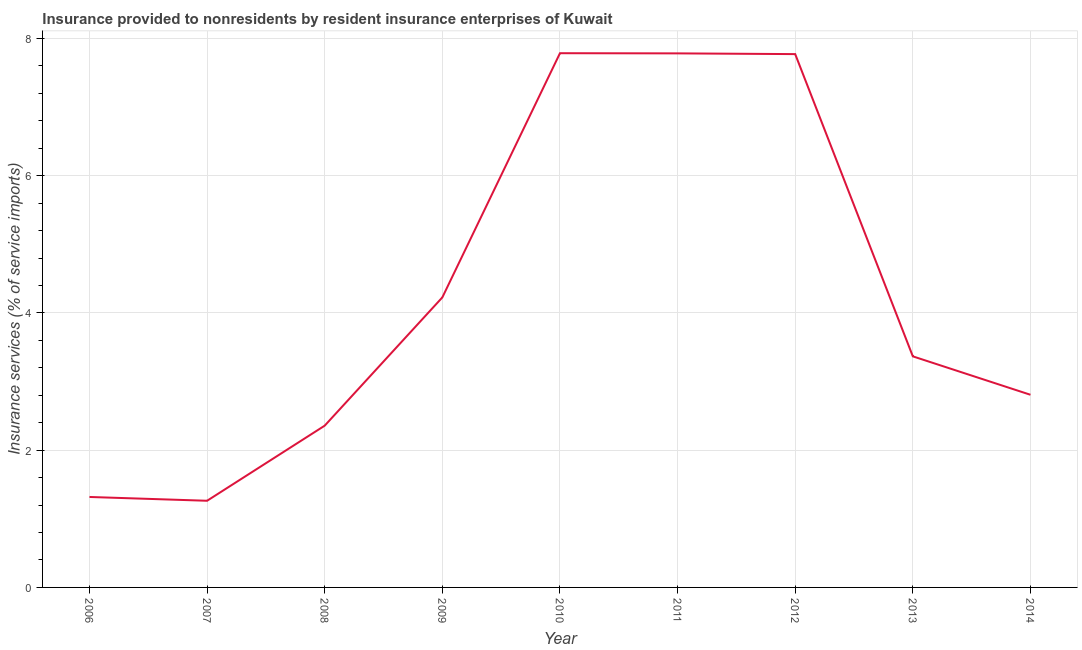What is the insurance and financial services in 2013?
Provide a succinct answer. 3.37. Across all years, what is the maximum insurance and financial services?
Ensure brevity in your answer.  7.79. Across all years, what is the minimum insurance and financial services?
Your answer should be very brief. 1.26. In which year was the insurance and financial services minimum?
Your response must be concise. 2007. What is the sum of the insurance and financial services?
Your response must be concise. 38.68. What is the difference between the insurance and financial services in 2009 and 2012?
Your answer should be compact. -3.55. What is the average insurance and financial services per year?
Offer a very short reply. 4.3. What is the median insurance and financial services?
Your response must be concise. 3.37. Do a majority of the years between 2009 and 2007 (inclusive) have insurance and financial services greater than 4 %?
Offer a very short reply. No. What is the ratio of the insurance and financial services in 2010 to that in 2012?
Your answer should be compact. 1. What is the difference between the highest and the second highest insurance and financial services?
Give a very brief answer. 0. Is the sum of the insurance and financial services in 2006 and 2012 greater than the maximum insurance and financial services across all years?
Provide a short and direct response. Yes. What is the difference between the highest and the lowest insurance and financial services?
Your answer should be compact. 6.52. Does the insurance and financial services monotonically increase over the years?
Provide a succinct answer. No. What is the difference between two consecutive major ticks on the Y-axis?
Keep it short and to the point. 2. Are the values on the major ticks of Y-axis written in scientific E-notation?
Ensure brevity in your answer.  No. Does the graph contain any zero values?
Your response must be concise. No. What is the title of the graph?
Provide a short and direct response. Insurance provided to nonresidents by resident insurance enterprises of Kuwait. What is the label or title of the X-axis?
Keep it short and to the point. Year. What is the label or title of the Y-axis?
Offer a terse response. Insurance services (% of service imports). What is the Insurance services (% of service imports) in 2006?
Your answer should be compact. 1.32. What is the Insurance services (% of service imports) in 2007?
Offer a terse response. 1.26. What is the Insurance services (% of service imports) of 2008?
Keep it short and to the point. 2.36. What is the Insurance services (% of service imports) of 2009?
Provide a short and direct response. 4.23. What is the Insurance services (% of service imports) of 2010?
Keep it short and to the point. 7.79. What is the Insurance services (% of service imports) in 2011?
Offer a very short reply. 7.78. What is the Insurance services (% of service imports) in 2012?
Keep it short and to the point. 7.77. What is the Insurance services (% of service imports) of 2013?
Ensure brevity in your answer.  3.37. What is the Insurance services (% of service imports) in 2014?
Your response must be concise. 2.81. What is the difference between the Insurance services (% of service imports) in 2006 and 2007?
Keep it short and to the point. 0.06. What is the difference between the Insurance services (% of service imports) in 2006 and 2008?
Ensure brevity in your answer.  -1.04. What is the difference between the Insurance services (% of service imports) in 2006 and 2009?
Give a very brief answer. -2.91. What is the difference between the Insurance services (% of service imports) in 2006 and 2010?
Make the answer very short. -6.47. What is the difference between the Insurance services (% of service imports) in 2006 and 2011?
Keep it short and to the point. -6.47. What is the difference between the Insurance services (% of service imports) in 2006 and 2012?
Provide a succinct answer. -6.45. What is the difference between the Insurance services (% of service imports) in 2006 and 2013?
Your answer should be very brief. -2.05. What is the difference between the Insurance services (% of service imports) in 2006 and 2014?
Your response must be concise. -1.49. What is the difference between the Insurance services (% of service imports) in 2007 and 2008?
Give a very brief answer. -1.09. What is the difference between the Insurance services (% of service imports) in 2007 and 2009?
Provide a short and direct response. -2.96. What is the difference between the Insurance services (% of service imports) in 2007 and 2010?
Provide a short and direct response. -6.52. What is the difference between the Insurance services (% of service imports) in 2007 and 2011?
Keep it short and to the point. -6.52. What is the difference between the Insurance services (% of service imports) in 2007 and 2012?
Ensure brevity in your answer.  -6.51. What is the difference between the Insurance services (% of service imports) in 2007 and 2013?
Make the answer very short. -2.1. What is the difference between the Insurance services (% of service imports) in 2007 and 2014?
Give a very brief answer. -1.54. What is the difference between the Insurance services (% of service imports) in 2008 and 2009?
Provide a succinct answer. -1.87. What is the difference between the Insurance services (% of service imports) in 2008 and 2010?
Provide a short and direct response. -5.43. What is the difference between the Insurance services (% of service imports) in 2008 and 2011?
Provide a short and direct response. -5.43. What is the difference between the Insurance services (% of service imports) in 2008 and 2012?
Your answer should be compact. -5.42. What is the difference between the Insurance services (% of service imports) in 2008 and 2013?
Your answer should be very brief. -1.01. What is the difference between the Insurance services (% of service imports) in 2008 and 2014?
Your answer should be compact. -0.45. What is the difference between the Insurance services (% of service imports) in 2009 and 2010?
Keep it short and to the point. -3.56. What is the difference between the Insurance services (% of service imports) in 2009 and 2011?
Keep it short and to the point. -3.56. What is the difference between the Insurance services (% of service imports) in 2009 and 2012?
Your answer should be very brief. -3.55. What is the difference between the Insurance services (% of service imports) in 2009 and 2013?
Ensure brevity in your answer.  0.86. What is the difference between the Insurance services (% of service imports) in 2009 and 2014?
Offer a very short reply. 1.42. What is the difference between the Insurance services (% of service imports) in 2010 and 2011?
Give a very brief answer. 0. What is the difference between the Insurance services (% of service imports) in 2010 and 2012?
Provide a short and direct response. 0.01. What is the difference between the Insurance services (% of service imports) in 2010 and 2013?
Offer a very short reply. 4.42. What is the difference between the Insurance services (% of service imports) in 2010 and 2014?
Give a very brief answer. 4.98. What is the difference between the Insurance services (% of service imports) in 2011 and 2012?
Offer a terse response. 0.01. What is the difference between the Insurance services (% of service imports) in 2011 and 2013?
Your answer should be compact. 4.42. What is the difference between the Insurance services (% of service imports) in 2011 and 2014?
Provide a succinct answer. 4.98. What is the difference between the Insurance services (% of service imports) in 2012 and 2013?
Keep it short and to the point. 4.4. What is the difference between the Insurance services (% of service imports) in 2012 and 2014?
Provide a short and direct response. 4.96. What is the difference between the Insurance services (% of service imports) in 2013 and 2014?
Offer a very short reply. 0.56. What is the ratio of the Insurance services (% of service imports) in 2006 to that in 2007?
Provide a succinct answer. 1.04. What is the ratio of the Insurance services (% of service imports) in 2006 to that in 2008?
Your response must be concise. 0.56. What is the ratio of the Insurance services (% of service imports) in 2006 to that in 2009?
Provide a succinct answer. 0.31. What is the ratio of the Insurance services (% of service imports) in 2006 to that in 2010?
Provide a short and direct response. 0.17. What is the ratio of the Insurance services (% of service imports) in 2006 to that in 2011?
Your response must be concise. 0.17. What is the ratio of the Insurance services (% of service imports) in 2006 to that in 2012?
Your answer should be very brief. 0.17. What is the ratio of the Insurance services (% of service imports) in 2006 to that in 2013?
Keep it short and to the point. 0.39. What is the ratio of the Insurance services (% of service imports) in 2006 to that in 2014?
Your response must be concise. 0.47. What is the ratio of the Insurance services (% of service imports) in 2007 to that in 2008?
Provide a succinct answer. 0.54. What is the ratio of the Insurance services (% of service imports) in 2007 to that in 2009?
Offer a terse response. 0.3. What is the ratio of the Insurance services (% of service imports) in 2007 to that in 2010?
Provide a succinct answer. 0.16. What is the ratio of the Insurance services (% of service imports) in 2007 to that in 2011?
Offer a terse response. 0.16. What is the ratio of the Insurance services (% of service imports) in 2007 to that in 2012?
Offer a terse response. 0.16. What is the ratio of the Insurance services (% of service imports) in 2007 to that in 2013?
Your answer should be very brief. 0.38. What is the ratio of the Insurance services (% of service imports) in 2007 to that in 2014?
Offer a terse response. 0.45. What is the ratio of the Insurance services (% of service imports) in 2008 to that in 2009?
Your answer should be very brief. 0.56. What is the ratio of the Insurance services (% of service imports) in 2008 to that in 2010?
Offer a terse response. 0.3. What is the ratio of the Insurance services (% of service imports) in 2008 to that in 2011?
Offer a very short reply. 0.3. What is the ratio of the Insurance services (% of service imports) in 2008 to that in 2012?
Your answer should be compact. 0.3. What is the ratio of the Insurance services (% of service imports) in 2008 to that in 2014?
Your answer should be very brief. 0.84. What is the ratio of the Insurance services (% of service imports) in 2009 to that in 2010?
Your answer should be compact. 0.54. What is the ratio of the Insurance services (% of service imports) in 2009 to that in 2011?
Make the answer very short. 0.54. What is the ratio of the Insurance services (% of service imports) in 2009 to that in 2012?
Your response must be concise. 0.54. What is the ratio of the Insurance services (% of service imports) in 2009 to that in 2013?
Your answer should be very brief. 1.25. What is the ratio of the Insurance services (% of service imports) in 2009 to that in 2014?
Make the answer very short. 1.5. What is the ratio of the Insurance services (% of service imports) in 2010 to that in 2013?
Your answer should be very brief. 2.31. What is the ratio of the Insurance services (% of service imports) in 2010 to that in 2014?
Make the answer very short. 2.77. What is the ratio of the Insurance services (% of service imports) in 2011 to that in 2013?
Provide a short and direct response. 2.31. What is the ratio of the Insurance services (% of service imports) in 2011 to that in 2014?
Your response must be concise. 2.77. What is the ratio of the Insurance services (% of service imports) in 2012 to that in 2013?
Your answer should be compact. 2.31. What is the ratio of the Insurance services (% of service imports) in 2012 to that in 2014?
Ensure brevity in your answer.  2.77. What is the ratio of the Insurance services (% of service imports) in 2013 to that in 2014?
Offer a very short reply. 1.2. 